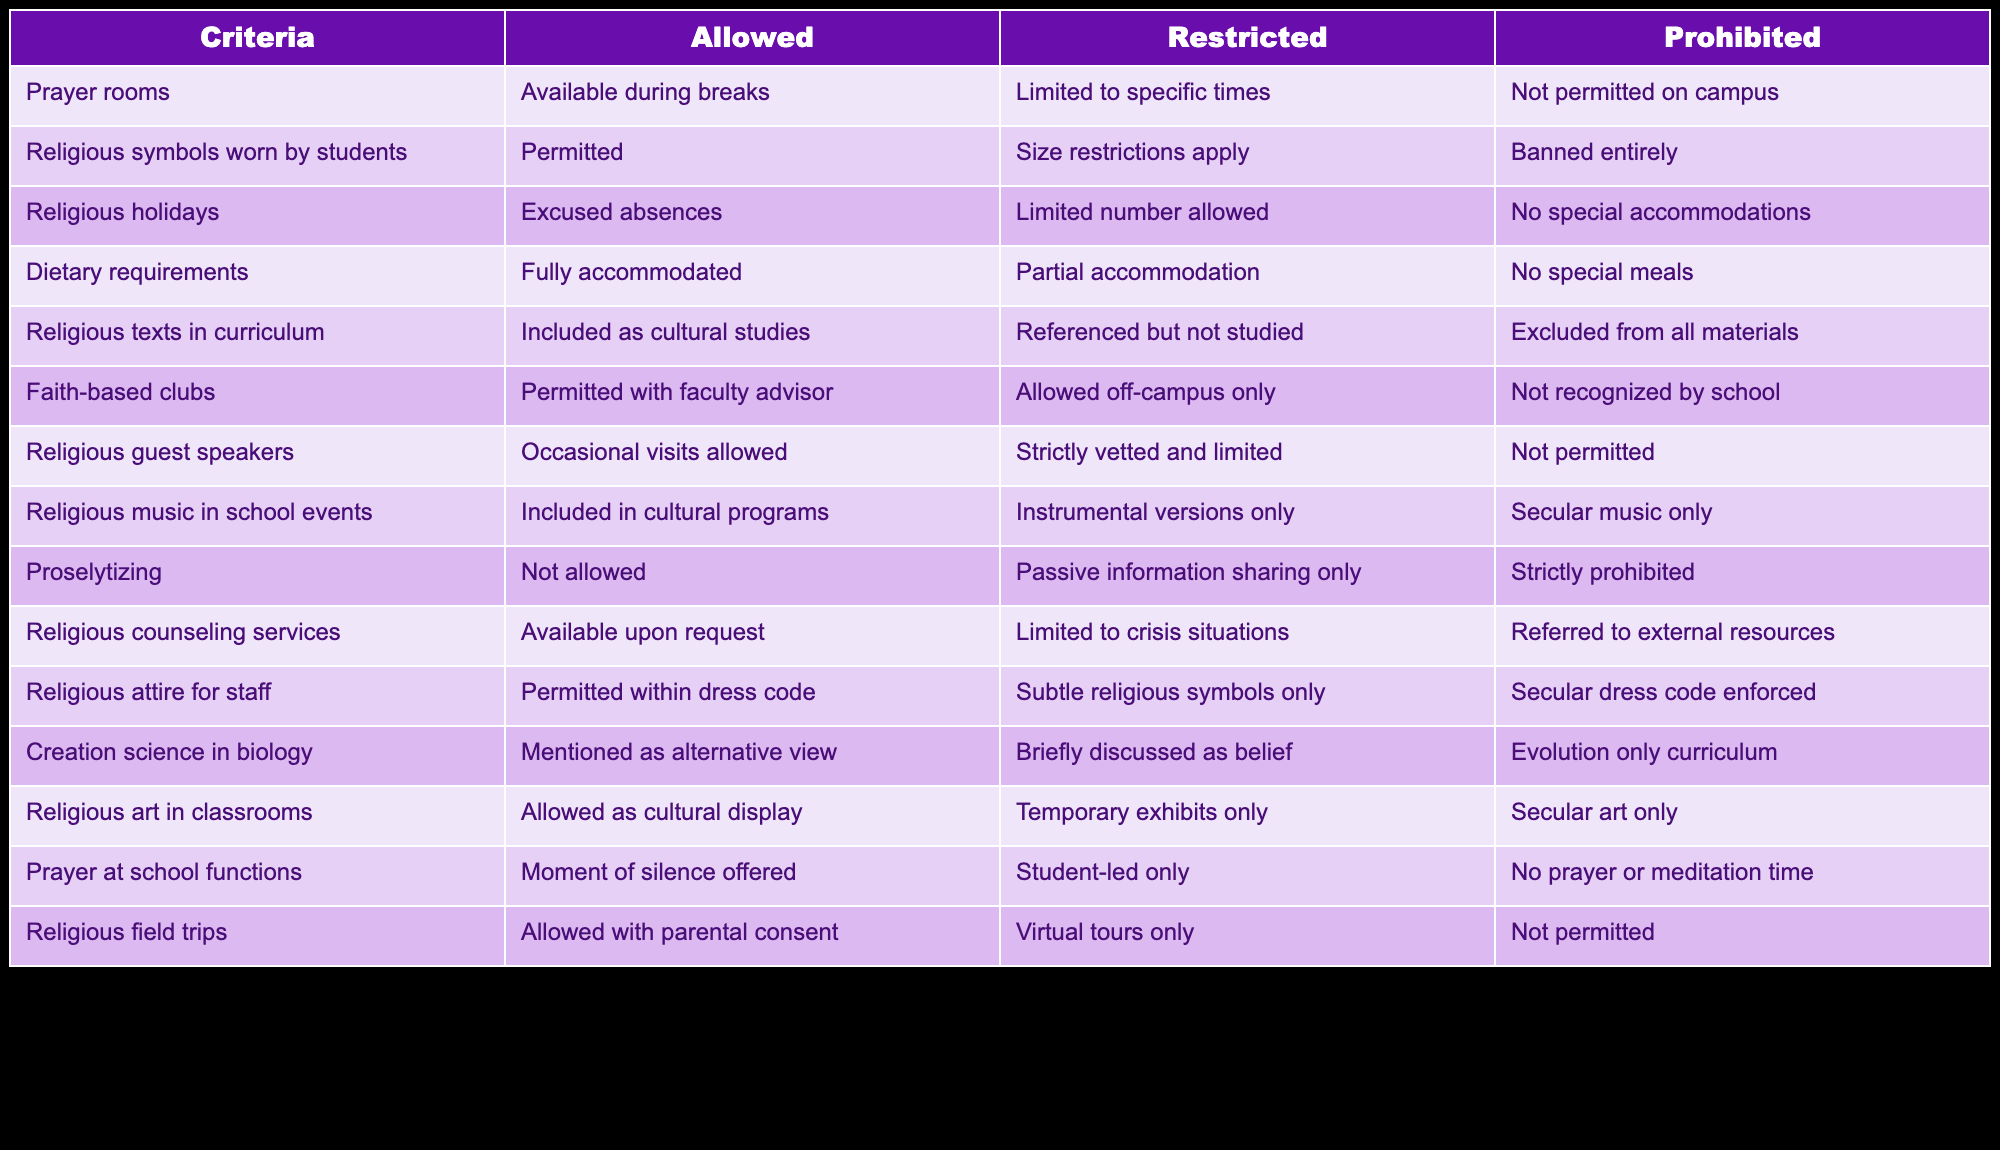What accommodations are made for dietary requirements? The table indicates that dietary requirements are fully accommodated, which means students requesting specific dietary needs can expect complete support from the educational setting.
Answer: Fully accommodated Are religious guest speakers allowed in this setting? According to the table, occasional visits by religious guest speakers are allowed, which suggests that there is some flexibility in allowing outside speakers with religious backgrounds to engage with students.
Answer: Occasional visits allowed Is proselytizing permitted in the educational context? The table clearly states that proselytizing is not allowed, indicating a strict policy against encouraging conversions or spreading specific religious beliefs within the school.
Answer: Not allowed How many categories are there for religious symbols worn by students? There are three categories for religious symbols: permitted, size restrictions apply, and banned entirely. This shows a clear classification of how these symbols can be managed in a secular educational environment.
Answer: Three categories What is the difference between how prayer at school functions and prayer rooms are treated? Prayer at school functions allows for a moment of silence, while prayer rooms are available during breaks, suggesting that prayer in communal settings is approached with different levels of acceptance and structure compared to individual spaces on campus.
Answer: Different levels of acceptance Are religious art displays allowed in classrooms? Yes, religious art in classrooms is allowed as a cultural display, which implies that the educational institution recognizes and accommodates the cultural significance of religious art.
Answer: Yes What would happen if a student wanted to organize a faith-based club without a faculty advisor? The policy states that faith-based clubs are permitted but must have a faculty advisor; therefore, a student organizing such a club without one would not be able to proceed under school rules.
Answer: They would not be permitted How many types of accommodations exist for religious holidays? There are three types of accommodations for religious holidays: excused absences, limited number allowed, and no special accommodations. Thus, there is a scale of support ranging from full acknowledgment to no recognition.
Answer: Three types 